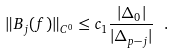Convert formula to latex. <formula><loc_0><loc_0><loc_500><loc_500>\| B _ { j } ( f ) \| _ { C ^ { 0 } } \leq c _ { 1 } \frac { | \Delta _ { 0 } | } { | \Delta _ { p - j } | } \ .</formula> 